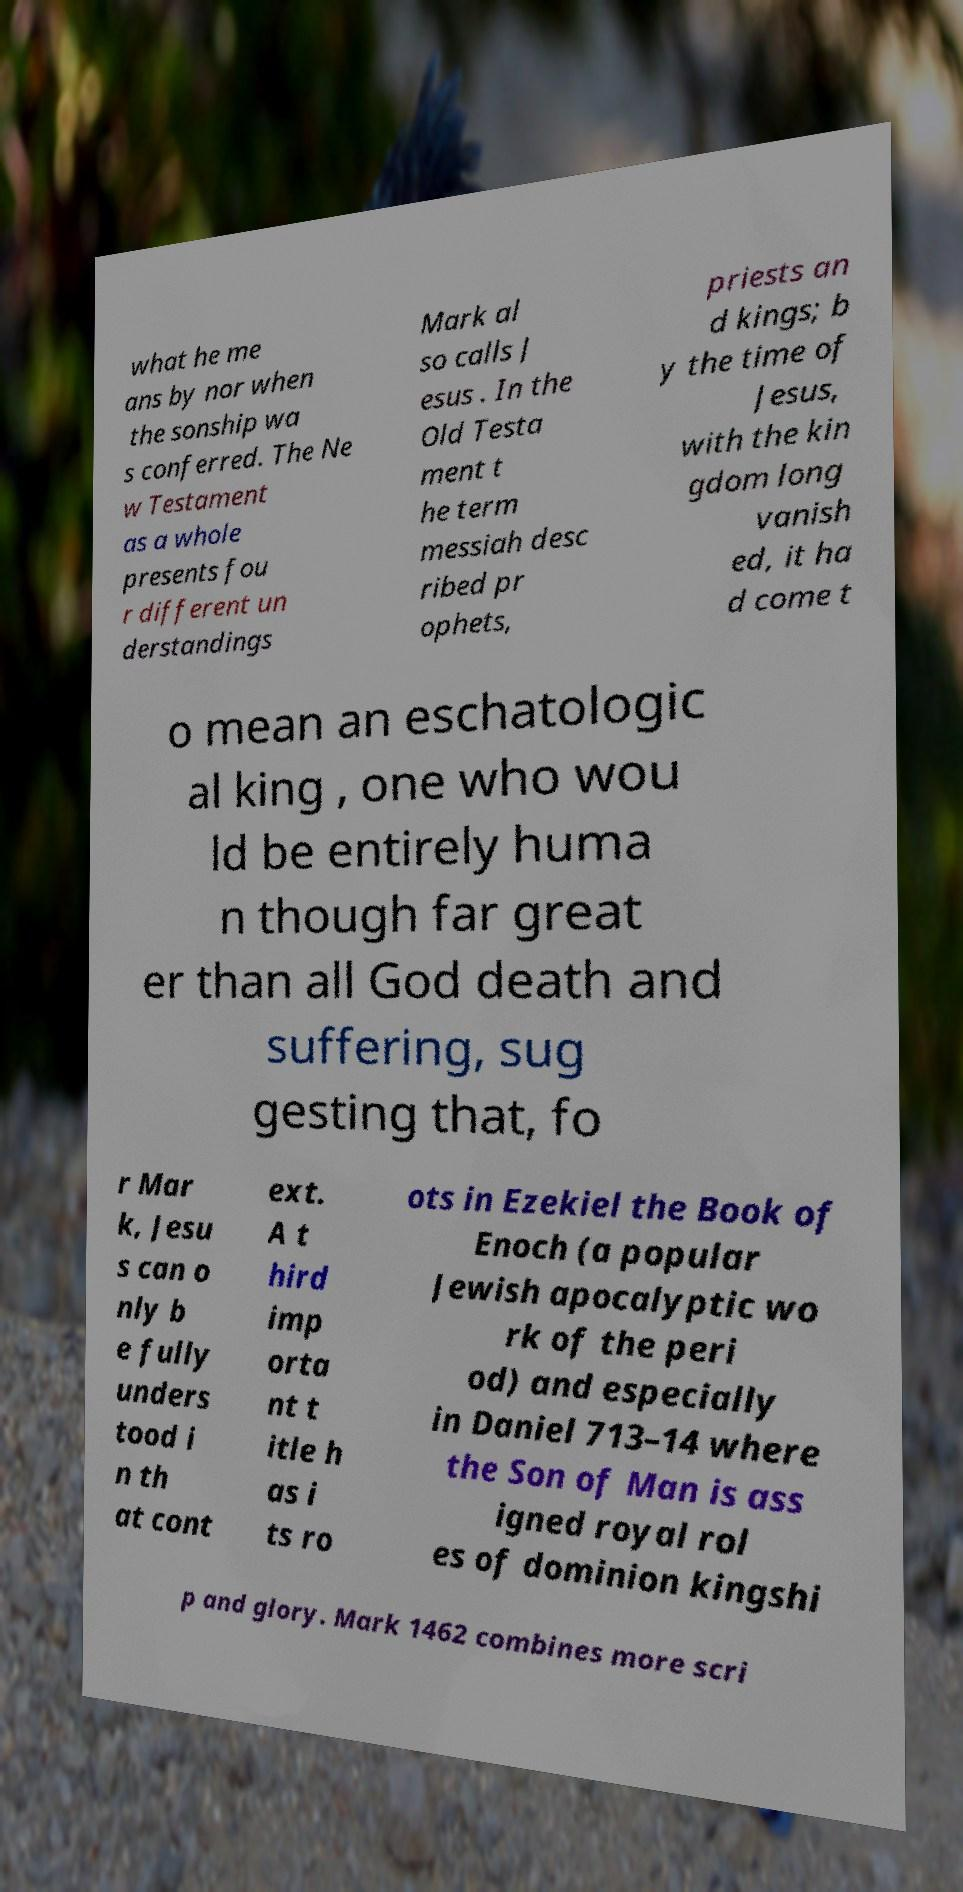Please read and relay the text visible in this image. What does it say? what he me ans by nor when the sonship wa s conferred. The Ne w Testament as a whole presents fou r different un derstandings Mark al so calls J esus . In the Old Testa ment t he term messiah desc ribed pr ophets, priests an d kings; b y the time of Jesus, with the kin gdom long vanish ed, it ha d come t o mean an eschatologic al king , one who wou ld be entirely huma n though far great er than all God death and suffering, sug gesting that, fo r Mar k, Jesu s can o nly b e fully unders tood i n th at cont ext. A t hird imp orta nt t itle h as i ts ro ots in Ezekiel the Book of Enoch (a popular Jewish apocalyptic wo rk of the peri od) and especially in Daniel 713–14 where the Son of Man is ass igned royal rol es of dominion kingshi p and glory. Mark 1462 combines more scri 